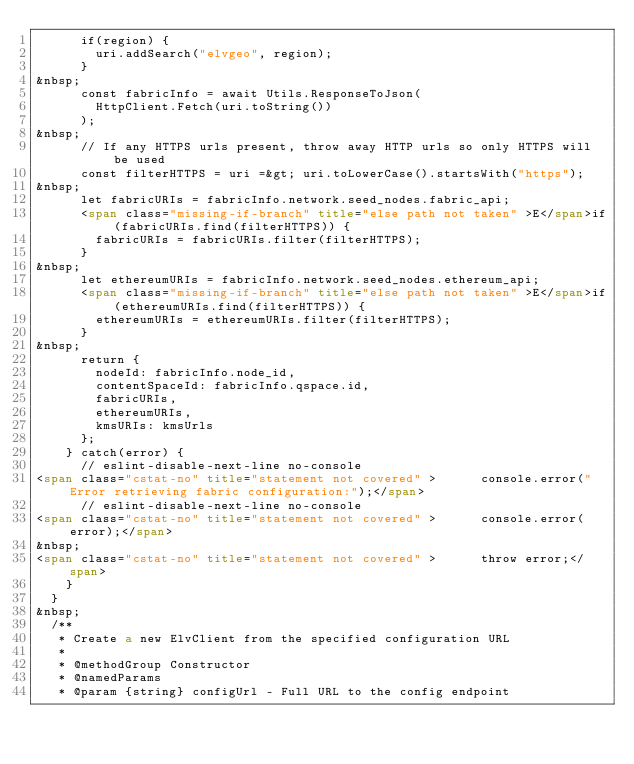<code> <loc_0><loc_0><loc_500><loc_500><_HTML_>      if(region) {
        uri.addSearch("elvgeo", region);
      }
&nbsp;
      const fabricInfo = await Utils.ResponseToJson(
        HttpClient.Fetch(uri.toString())
      );
&nbsp;
      // If any HTTPS urls present, throw away HTTP urls so only HTTPS will be used
      const filterHTTPS = uri =&gt; uri.toLowerCase().startsWith("https");
&nbsp;
      let fabricURIs = fabricInfo.network.seed_nodes.fabric_api;
      <span class="missing-if-branch" title="else path not taken" >E</span>if(fabricURIs.find(filterHTTPS)) {
        fabricURIs = fabricURIs.filter(filterHTTPS);
      }
&nbsp;
      let ethereumURIs = fabricInfo.network.seed_nodes.ethereum_api;
      <span class="missing-if-branch" title="else path not taken" >E</span>if(ethereumURIs.find(filterHTTPS)) {
        ethereumURIs = ethereumURIs.filter(filterHTTPS);
      }
&nbsp;
      return {
        nodeId: fabricInfo.node_id,
        contentSpaceId: fabricInfo.qspace.id,
        fabricURIs,
        ethereumURIs,
        kmsURIs: kmsUrls
      };
    } catch(error) {
      // eslint-disable-next-line no-console
<span class="cstat-no" title="statement not covered" >      console.error("Error retrieving fabric configuration:");</span>
      // eslint-disable-next-line no-console
<span class="cstat-no" title="statement not covered" >      console.error(error);</span>
&nbsp;
<span class="cstat-no" title="statement not covered" >      throw error;</span>
    }
  }
&nbsp;
  /**
   * Create a new ElvClient from the specified configuration URL
   *
   * @methodGroup Constructor
   * @namedParams
   * @param {string} configUrl - Full URL to the config endpoint</code> 